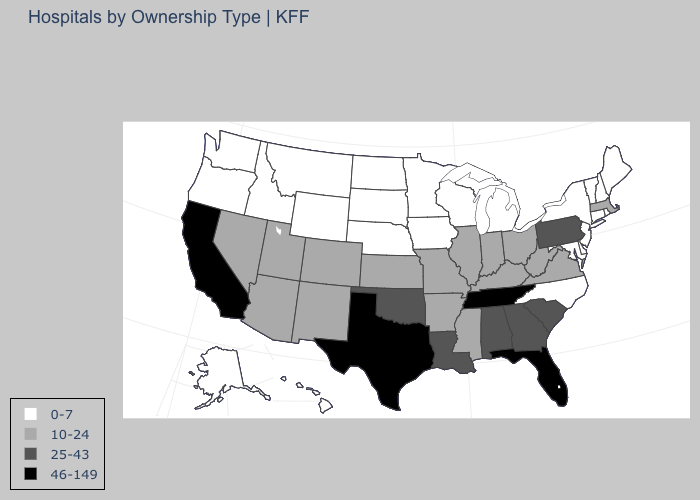What is the value of Texas?
Be succinct. 46-149. Name the states that have a value in the range 0-7?
Short answer required. Alaska, Connecticut, Delaware, Hawaii, Idaho, Iowa, Maine, Maryland, Michigan, Minnesota, Montana, Nebraska, New Hampshire, New Jersey, New York, North Carolina, North Dakota, Oregon, Rhode Island, South Dakota, Vermont, Washington, Wisconsin, Wyoming. What is the value of Idaho?
Be succinct. 0-7. Does the map have missing data?
Quick response, please. No. Which states have the highest value in the USA?
Short answer required. California, Florida, Tennessee, Texas. Does Florida have the highest value in the USA?
Concise answer only. Yes. Does the first symbol in the legend represent the smallest category?
Quick response, please. Yes. Does Louisiana have the same value as Maryland?
Write a very short answer. No. What is the highest value in states that border Arizona?
Short answer required. 46-149. Which states have the lowest value in the South?
Answer briefly. Delaware, Maryland, North Carolina. Name the states that have a value in the range 0-7?
Write a very short answer. Alaska, Connecticut, Delaware, Hawaii, Idaho, Iowa, Maine, Maryland, Michigan, Minnesota, Montana, Nebraska, New Hampshire, New Jersey, New York, North Carolina, North Dakota, Oregon, Rhode Island, South Dakota, Vermont, Washington, Wisconsin, Wyoming. Among the states that border North Carolina , which have the highest value?
Keep it brief. Tennessee. Which states have the lowest value in the USA?
Be succinct. Alaska, Connecticut, Delaware, Hawaii, Idaho, Iowa, Maine, Maryland, Michigan, Minnesota, Montana, Nebraska, New Hampshire, New Jersey, New York, North Carolina, North Dakota, Oregon, Rhode Island, South Dakota, Vermont, Washington, Wisconsin, Wyoming. Name the states that have a value in the range 10-24?
Be succinct. Arizona, Arkansas, Colorado, Illinois, Indiana, Kansas, Kentucky, Massachusetts, Mississippi, Missouri, Nevada, New Mexico, Ohio, Utah, Virginia, West Virginia. Name the states that have a value in the range 10-24?
Write a very short answer. Arizona, Arkansas, Colorado, Illinois, Indiana, Kansas, Kentucky, Massachusetts, Mississippi, Missouri, Nevada, New Mexico, Ohio, Utah, Virginia, West Virginia. 